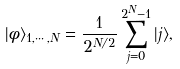<formula> <loc_0><loc_0><loc_500><loc_500>| \phi \rangle _ { 1 , \cdots , N } = \frac { 1 } { 2 ^ { N / 2 } } \sum _ { j = 0 } ^ { 2 ^ { N } - 1 } | j \rangle ,</formula> 